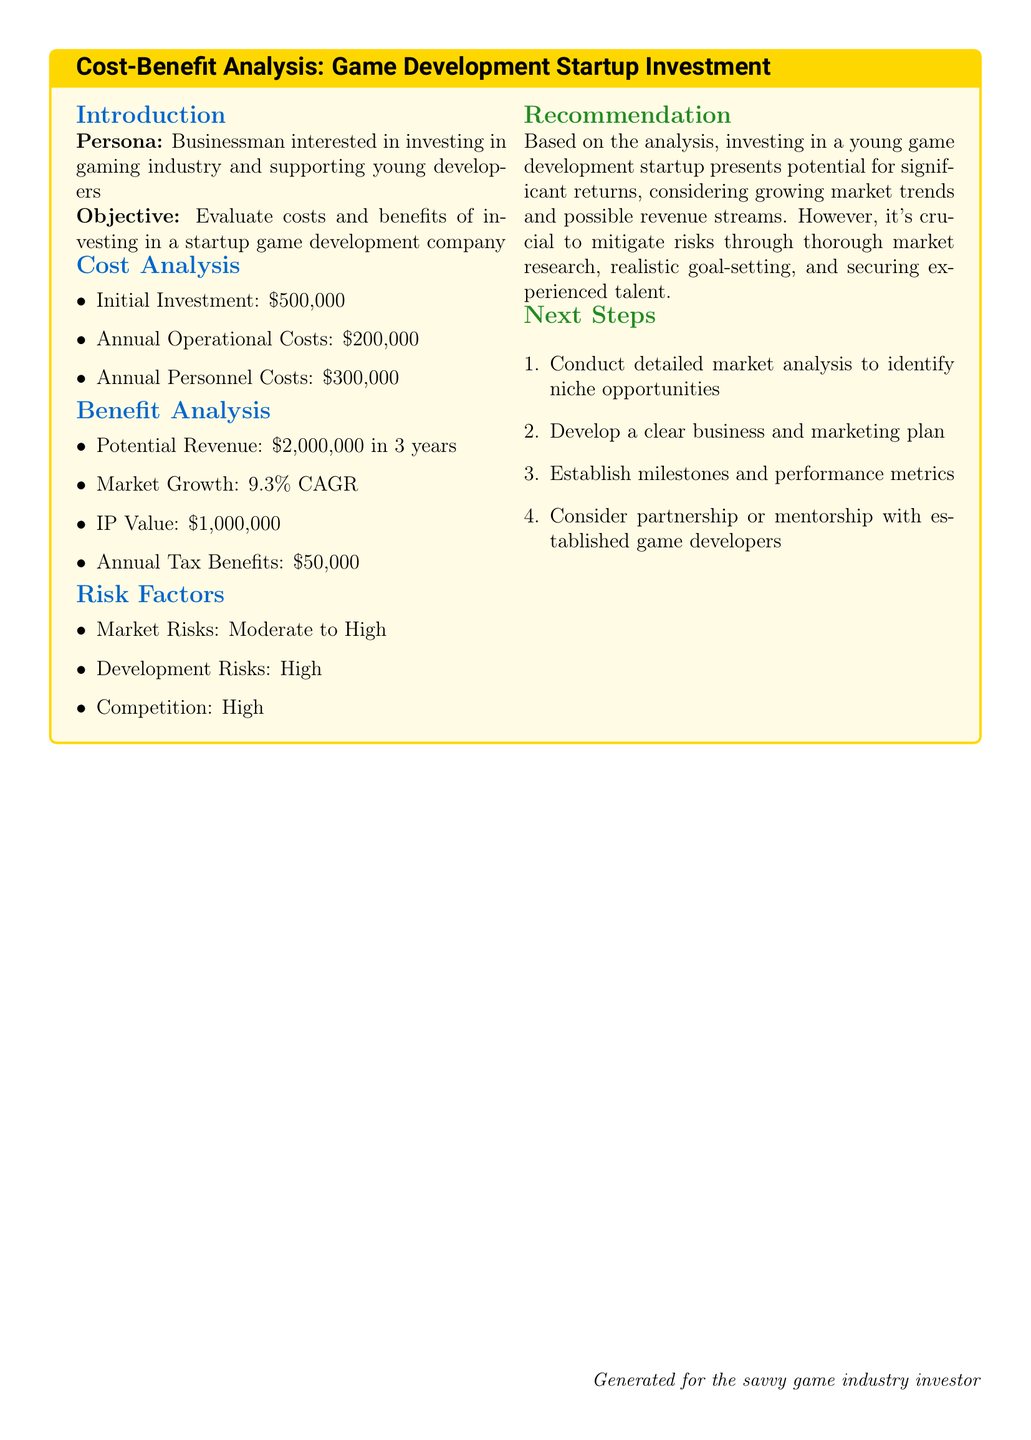What is the initial investment amount? The initial investment is explicitly stated in the cost analysis section of the document.
Answer: $500,000 What are the annual operational costs? The annual operational costs are clearly listed under the cost analysis section.
Answer: $200,000 What is the potential revenue in three years? The potential revenue is specified in the benefit analysis section of the document.
Answer: $2,000,000 What is the market growth rate mentioned? The document provides the compound annual growth rate (CAGR) in the benefit analysis section.
Answer: 9.3% What is the estimated IP value? The estimated IP value is detailed in the benefit analysis of the document.
Answer: $1,000,000 What are the annual tax benefits? The annual tax benefits figure is included in the benefit analysis section of the document.
Answer: $50,000 What are the risk factors mentioned? The document lists market risks, development risks, and competition, showing the potential challenges.
Answer: Moderate to High What is the first next step recommended? The recommendation section suggests conducting a specific activity as the first step for investors.
Answer: Conduct detailed market analysis What is the overall recommendation regarding investment? The recommendation provides a summary opinion based on the analysis presented in the document.
Answer: Significant returns potential 